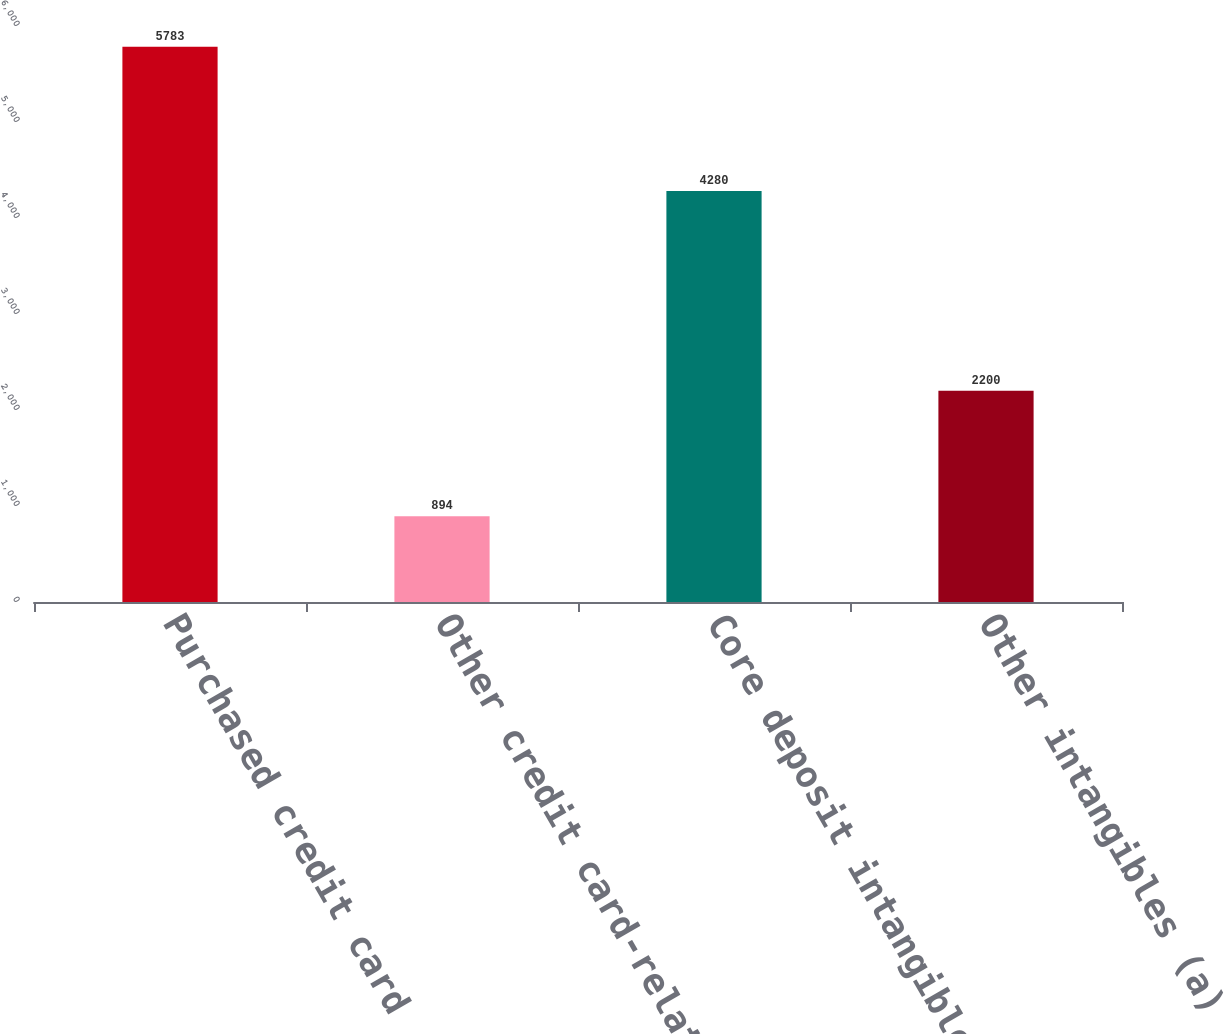Convert chart. <chart><loc_0><loc_0><loc_500><loc_500><bar_chart><fcel>Purchased credit card<fcel>Other credit card-related<fcel>Core deposit intangibles<fcel>Other intangibles (a)<nl><fcel>5783<fcel>894<fcel>4280<fcel>2200<nl></chart> 